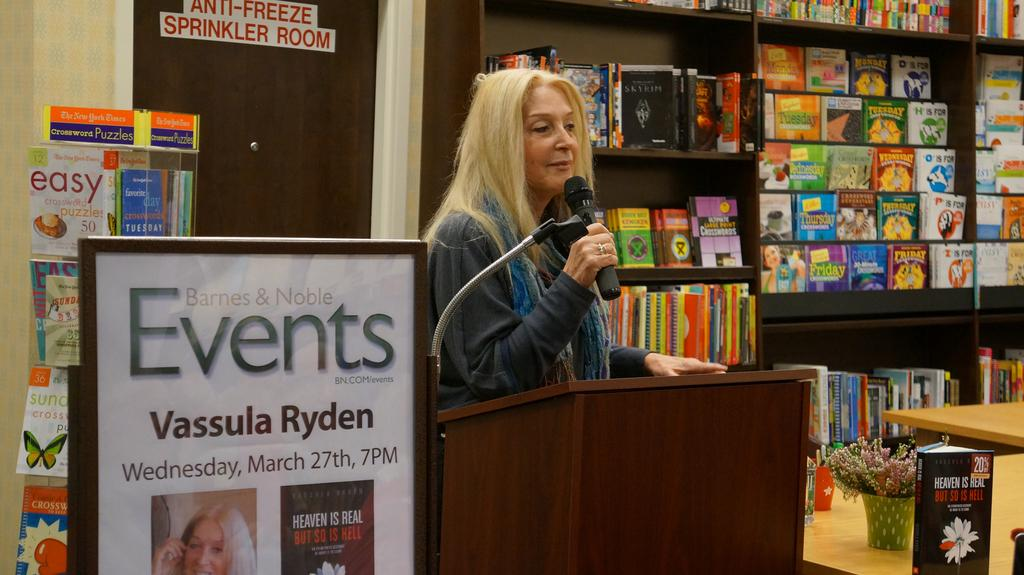<image>
Create a compact narrative representing the image presented. Vassula Ryden speaks into microphone in a Barnes and Noble store. 